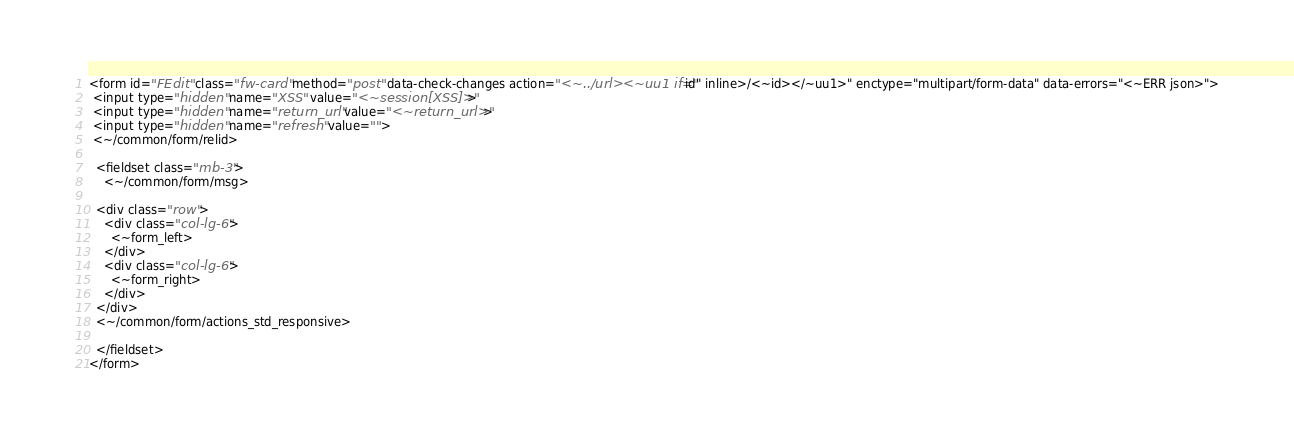Convert code to text. <code><loc_0><loc_0><loc_500><loc_500><_HTML_><form id="FEdit" class="fw-card" method="post" data-check-changes action="<~../url><~uu1 if="id" inline>/<~id></~uu1>" enctype="multipart/form-data" data-errors="<~ERR json>">
 <input type="hidden" name="XSS" value="<~session[XSS]>">
 <input type="hidden" name="return_url" value="<~return_url>">
 <input type="hidden" name="refresh" value="">
 <~/common/form/relid>

  <fieldset class="mb-3">
    <~/common/form/msg>

  <div class="row">
    <div class="col-lg-6">
      <~form_left>
    </div>
    <div class="col-lg-6">
      <~form_right>
    </div>
  </div>
  <~/common/form/actions_std_responsive>

  </fieldset>
</form></code> 